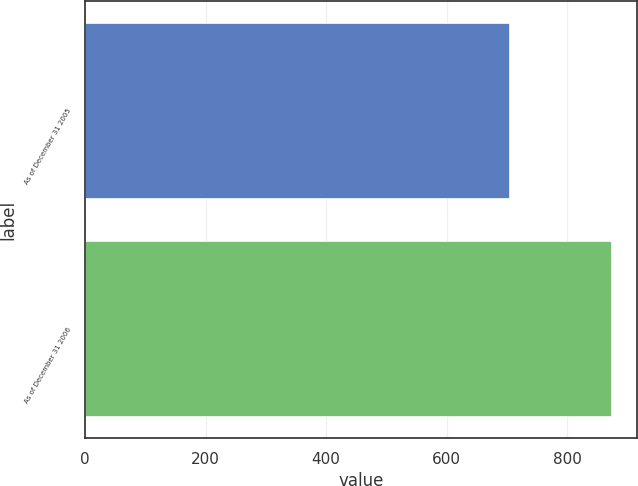<chart> <loc_0><loc_0><loc_500><loc_500><bar_chart><fcel>As of December 31 2005<fcel>As of December 31 2006<nl><fcel>704<fcel>872<nl></chart> 